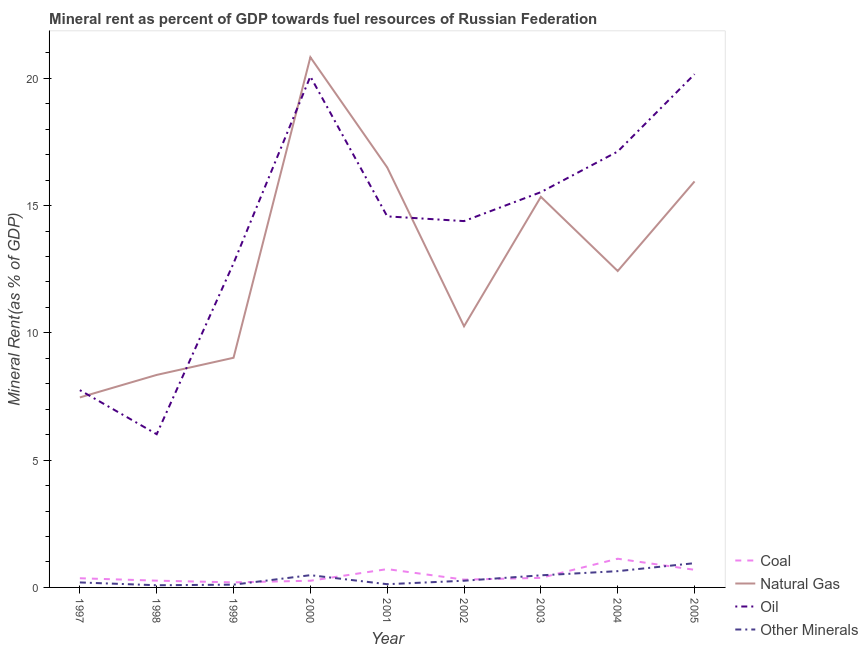How many different coloured lines are there?
Offer a terse response. 4. Does the line corresponding to coal rent intersect with the line corresponding to  rent of other minerals?
Give a very brief answer. Yes. What is the natural gas rent in 2000?
Offer a very short reply. 20.83. Across all years, what is the maximum coal rent?
Keep it short and to the point. 1.13. Across all years, what is the minimum coal rent?
Your answer should be very brief. 0.2. In which year was the natural gas rent maximum?
Your response must be concise. 2000. In which year was the natural gas rent minimum?
Ensure brevity in your answer.  1997. What is the total  rent of other minerals in the graph?
Your answer should be compact. 3.33. What is the difference between the  rent of other minerals in 1999 and that in 2001?
Ensure brevity in your answer.  -0.02. What is the difference between the  rent of other minerals in 2005 and the coal rent in 2003?
Give a very brief answer. 0.58. What is the average  rent of other minerals per year?
Offer a terse response. 0.37. In the year 1997, what is the difference between the  rent of other minerals and coal rent?
Provide a succinct answer. -0.16. In how many years, is the  rent of other minerals greater than 18 %?
Your answer should be very brief. 0. What is the ratio of the  rent of other minerals in 1997 to that in 2004?
Make the answer very short. 0.31. Is the difference between the  rent of other minerals in 2000 and 2003 greater than the difference between the coal rent in 2000 and 2003?
Your response must be concise. Yes. What is the difference between the highest and the second highest oil rent?
Your answer should be compact. 0.09. What is the difference between the highest and the lowest oil rent?
Give a very brief answer. 14.14. In how many years, is the  rent of other minerals greater than the average  rent of other minerals taken over all years?
Provide a succinct answer. 4. Is it the case that in every year, the sum of the coal rent and natural gas rent is greater than the oil rent?
Provide a succinct answer. No. Does the oil rent monotonically increase over the years?
Your response must be concise. No. Is the coal rent strictly less than the  rent of other minerals over the years?
Offer a very short reply. No. How many years are there in the graph?
Offer a terse response. 9. What is the difference between two consecutive major ticks on the Y-axis?
Your answer should be compact. 5. Are the values on the major ticks of Y-axis written in scientific E-notation?
Ensure brevity in your answer.  No. Does the graph contain grids?
Provide a short and direct response. No. Where does the legend appear in the graph?
Your answer should be very brief. Bottom right. How many legend labels are there?
Your answer should be very brief. 4. What is the title of the graph?
Offer a very short reply. Mineral rent as percent of GDP towards fuel resources of Russian Federation. What is the label or title of the Y-axis?
Offer a very short reply. Mineral Rent(as % of GDP). What is the Mineral Rent(as % of GDP) in Coal in 1997?
Offer a terse response. 0.36. What is the Mineral Rent(as % of GDP) in Natural Gas in 1997?
Offer a very short reply. 7.46. What is the Mineral Rent(as % of GDP) of Oil in 1997?
Offer a terse response. 7.75. What is the Mineral Rent(as % of GDP) in Other Minerals in 1997?
Your answer should be very brief. 0.2. What is the Mineral Rent(as % of GDP) in Coal in 1998?
Keep it short and to the point. 0.27. What is the Mineral Rent(as % of GDP) in Natural Gas in 1998?
Keep it short and to the point. 8.35. What is the Mineral Rent(as % of GDP) of Oil in 1998?
Ensure brevity in your answer.  6.02. What is the Mineral Rent(as % of GDP) in Other Minerals in 1998?
Give a very brief answer. 0.09. What is the Mineral Rent(as % of GDP) of Coal in 1999?
Your answer should be very brief. 0.2. What is the Mineral Rent(as % of GDP) in Natural Gas in 1999?
Provide a succinct answer. 9.02. What is the Mineral Rent(as % of GDP) in Oil in 1999?
Your response must be concise. 12.73. What is the Mineral Rent(as % of GDP) of Other Minerals in 1999?
Your response must be concise. 0.11. What is the Mineral Rent(as % of GDP) in Coal in 2000?
Offer a terse response. 0.26. What is the Mineral Rent(as % of GDP) of Natural Gas in 2000?
Provide a succinct answer. 20.83. What is the Mineral Rent(as % of GDP) in Oil in 2000?
Offer a very short reply. 20.07. What is the Mineral Rent(as % of GDP) of Other Minerals in 2000?
Keep it short and to the point. 0.48. What is the Mineral Rent(as % of GDP) of Coal in 2001?
Your answer should be very brief. 0.72. What is the Mineral Rent(as % of GDP) in Natural Gas in 2001?
Your answer should be compact. 16.5. What is the Mineral Rent(as % of GDP) in Oil in 2001?
Offer a terse response. 14.57. What is the Mineral Rent(as % of GDP) in Other Minerals in 2001?
Give a very brief answer. 0.13. What is the Mineral Rent(as % of GDP) of Coal in 2002?
Provide a succinct answer. 0.31. What is the Mineral Rent(as % of GDP) of Natural Gas in 2002?
Offer a terse response. 10.26. What is the Mineral Rent(as % of GDP) in Oil in 2002?
Your answer should be very brief. 14.39. What is the Mineral Rent(as % of GDP) of Other Minerals in 2002?
Give a very brief answer. 0.26. What is the Mineral Rent(as % of GDP) in Coal in 2003?
Make the answer very short. 0.38. What is the Mineral Rent(as % of GDP) in Natural Gas in 2003?
Provide a short and direct response. 15.34. What is the Mineral Rent(as % of GDP) of Oil in 2003?
Offer a terse response. 15.53. What is the Mineral Rent(as % of GDP) of Other Minerals in 2003?
Provide a succinct answer. 0.48. What is the Mineral Rent(as % of GDP) in Coal in 2004?
Ensure brevity in your answer.  1.13. What is the Mineral Rent(as % of GDP) of Natural Gas in 2004?
Your answer should be compact. 12.43. What is the Mineral Rent(as % of GDP) in Oil in 2004?
Provide a succinct answer. 17.12. What is the Mineral Rent(as % of GDP) in Other Minerals in 2004?
Your response must be concise. 0.64. What is the Mineral Rent(as % of GDP) of Coal in 2005?
Keep it short and to the point. 0.69. What is the Mineral Rent(as % of GDP) in Natural Gas in 2005?
Keep it short and to the point. 15.95. What is the Mineral Rent(as % of GDP) of Oil in 2005?
Give a very brief answer. 20.16. What is the Mineral Rent(as % of GDP) of Other Minerals in 2005?
Ensure brevity in your answer.  0.95. Across all years, what is the maximum Mineral Rent(as % of GDP) in Coal?
Make the answer very short. 1.13. Across all years, what is the maximum Mineral Rent(as % of GDP) in Natural Gas?
Give a very brief answer. 20.83. Across all years, what is the maximum Mineral Rent(as % of GDP) of Oil?
Your answer should be compact. 20.16. Across all years, what is the maximum Mineral Rent(as % of GDP) in Other Minerals?
Your answer should be very brief. 0.95. Across all years, what is the minimum Mineral Rent(as % of GDP) of Coal?
Give a very brief answer. 0.2. Across all years, what is the minimum Mineral Rent(as % of GDP) of Natural Gas?
Make the answer very short. 7.46. Across all years, what is the minimum Mineral Rent(as % of GDP) in Oil?
Your answer should be compact. 6.02. Across all years, what is the minimum Mineral Rent(as % of GDP) of Other Minerals?
Offer a very short reply. 0.09. What is the total Mineral Rent(as % of GDP) of Coal in the graph?
Make the answer very short. 4.31. What is the total Mineral Rent(as % of GDP) in Natural Gas in the graph?
Keep it short and to the point. 116.13. What is the total Mineral Rent(as % of GDP) in Oil in the graph?
Keep it short and to the point. 128.34. What is the total Mineral Rent(as % of GDP) in Other Minerals in the graph?
Give a very brief answer. 3.33. What is the difference between the Mineral Rent(as % of GDP) in Coal in 1997 and that in 1998?
Offer a terse response. 0.09. What is the difference between the Mineral Rent(as % of GDP) in Natural Gas in 1997 and that in 1998?
Ensure brevity in your answer.  -0.88. What is the difference between the Mineral Rent(as % of GDP) in Oil in 1997 and that in 1998?
Your response must be concise. 1.73. What is the difference between the Mineral Rent(as % of GDP) in Other Minerals in 1997 and that in 1998?
Ensure brevity in your answer.  0.11. What is the difference between the Mineral Rent(as % of GDP) of Coal in 1997 and that in 1999?
Offer a very short reply. 0.16. What is the difference between the Mineral Rent(as % of GDP) in Natural Gas in 1997 and that in 1999?
Give a very brief answer. -1.56. What is the difference between the Mineral Rent(as % of GDP) in Oil in 1997 and that in 1999?
Ensure brevity in your answer.  -4.98. What is the difference between the Mineral Rent(as % of GDP) of Other Minerals in 1997 and that in 1999?
Keep it short and to the point. 0.09. What is the difference between the Mineral Rent(as % of GDP) in Coal in 1997 and that in 2000?
Your response must be concise. 0.1. What is the difference between the Mineral Rent(as % of GDP) of Natural Gas in 1997 and that in 2000?
Make the answer very short. -13.36. What is the difference between the Mineral Rent(as % of GDP) of Oil in 1997 and that in 2000?
Offer a very short reply. -12.32. What is the difference between the Mineral Rent(as % of GDP) of Other Minerals in 1997 and that in 2000?
Your answer should be very brief. -0.29. What is the difference between the Mineral Rent(as % of GDP) in Coal in 1997 and that in 2001?
Ensure brevity in your answer.  -0.36. What is the difference between the Mineral Rent(as % of GDP) in Natural Gas in 1997 and that in 2001?
Your answer should be compact. -9.03. What is the difference between the Mineral Rent(as % of GDP) of Oil in 1997 and that in 2001?
Your answer should be compact. -6.83. What is the difference between the Mineral Rent(as % of GDP) of Other Minerals in 1997 and that in 2001?
Provide a short and direct response. 0.07. What is the difference between the Mineral Rent(as % of GDP) in Coal in 1997 and that in 2002?
Your response must be concise. 0.05. What is the difference between the Mineral Rent(as % of GDP) of Natural Gas in 1997 and that in 2002?
Provide a short and direct response. -2.8. What is the difference between the Mineral Rent(as % of GDP) of Oil in 1997 and that in 2002?
Offer a very short reply. -6.64. What is the difference between the Mineral Rent(as % of GDP) of Other Minerals in 1997 and that in 2002?
Ensure brevity in your answer.  -0.07. What is the difference between the Mineral Rent(as % of GDP) in Coal in 1997 and that in 2003?
Your answer should be very brief. -0.02. What is the difference between the Mineral Rent(as % of GDP) in Natural Gas in 1997 and that in 2003?
Your answer should be very brief. -7.88. What is the difference between the Mineral Rent(as % of GDP) in Oil in 1997 and that in 2003?
Offer a terse response. -7.78. What is the difference between the Mineral Rent(as % of GDP) of Other Minerals in 1997 and that in 2003?
Provide a succinct answer. -0.28. What is the difference between the Mineral Rent(as % of GDP) of Coal in 1997 and that in 2004?
Your response must be concise. -0.77. What is the difference between the Mineral Rent(as % of GDP) of Natural Gas in 1997 and that in 2004?
Your answer should be compact. -4.97. What is the difference between the Mineral Rent(as % of GDP) in Oil in 1997 and that in 2004?
Provide a succinct answer. -9.37. What is the difference between the Mineral Rent(as % of GDP) in Other Minerals in 1997 and that in 2004?
Your answer should be compact. -0.44. What is the difference between the Mineral Rent(as % of GDP) in Coal in 1997 and that in 2005?
Provide a short and direct response. -0.33. What is the difference between the Mineral Rent(as % of GDP) in Natural Gas in 1997 and that in 2005?
Give a very brief answer. -8.48. What is the difference between the Mineral Rent(as % of GDP) of Oil in 1997 and that in 2005?
Offer a terse response. -12.41. What is the difference between the Mineral Rent(as % of GDP) of Other Minerals in 1997 and that in 2005?
Your answer should be very brief. -0.76. What is the difference between the Mineral Rent(as % of GDP) of Coal in 1998 and that in 1999?
Offer a very short reply. 0.07. What is the difference between the Mineral Rent(as % of GDP) in Natural Gas in 1998 and that in 1999?
Provide a succinct answer. -0.67. What is the difference between the Mineral Rent(as % of GDP) in Oil in 1998 and that in 1999?
Your response must be concise. -6.71. What is the difference between the Mineral Rent(as % of GDP) of Other Minerals in 1998 and that in 1999?
Provide a succinct answer. -0.02. What is the difference between the Mineral Rent(as % of GDP) in Coal in 1998 and that in 2000?
Your answer should be compact. 0. What is the difference between the Mineral Rent(as % of GDP) of Natural Gas in 1998 and that in 2000?
Your answer should be very brief. -12.48. What is the difference between the Mineral Rent(as % of GDP) in Oil in 1998 and that in 2000?
Give a very brief answer. -14.05. What is the difference between the Mineral Rent(as % of GDP) of Other Minerals in 1998 and that in 2000?
Your answer should be very brief. -0.4. What is the difference between the Mineral Rent(as % of GDP) in Coal in 1998 and that in 2001?
Provide a succinct answer. -0.45. What is the difference between the Mineral Rent(as % of GDP) in Natural Gas in 1998 and that in 2001?
Your response must be concise. -8.15. What is the difference between the Mineral Rent(as % of GDP) of Oil in 1998 and that in 2001?
Provide a short and direct response. -8.56. What is the difference between the Mineral Rent(as % of GDP) in Other Minerals in 1998 and that in 2001?
Provide a succinct answer. -0.04. What is the difference between the Mineral Rent(as % of GDP) of Coal in 1998 and that in 2002?
Give a very brief answer. -0.04. What is the difference between the Mineral Rent(as % of GDP) of Natural Gas in 1998 and that in 2002?
Provide a short and direct response. -1.91. What is the difference between the Mineral Rent(as % of GDP) in Oil in 1998 and that in 2002?
Your response must be concise. -8.37. What is the difference between the Mineral Rent(as % of GDP) in Other Minerals in 1998 and that in 2002?
Offer a very short reply. -0.18. What is the difference between the Mineral Rent(as % of GDP) of Coal in 1998 and that in 2003?
Provide a short and direct response. -0.11. What is the difference between the Mineral Rent(as % of GDP) in Natural Gas in 1998 and that in 2003?
Provide a short and direct response. -7. What is the difference between the Mineral Rent(as % of GDP) in Oil in 1998 and that in 2003?
Keep it short and to the point. -9.51. What is the difference between the Mineral Rent(as % of GDP) of Other Minerals in 1998 and that in 2003?
Your answer should be very brief. -0.39. What is the difference between the Mineral Rent(as % of GDP) in Coal in 1998 and that in 2004?
Give a very brief answer. -0.86. What is the difference between the Mineral Rent(as % of GDP) in Natural Gas in 1998 and that in 2004?
Make the answer very short. -4.08. What is the difference between the Mineral Rent(as % of GDP) of Oil in 1998 and that in 2004?
Your response must be concise. -11.1. What is the difference between the Mineral Rent(as % of GDP) of Other Minerals in 1998 and that in 2004?
Ensure brevity in your answer.  -0.55. What is the difference between the Mineral Rent(as % of GDP) of Coal in 1998 and that in 2005?
Ensure brevity in your answer.  -0.43. What is the difference between the Mineral Rent(as % of GDP) in Natural Gas in 1998 and that in 2005?
Your answer should be compact. -7.6. What is the difference between the Mineral Rent(as % of GDP) of Oil in 1998 and that in 2005?
Your answer should be compact. -14.14. What is the difference between the Mineral Rent(as % of GDP) of Other Minerals in 1998 and that in 2005?
Your answer should be very brief. -0.87. What is the difference between the Mineral Rent(as % of GDP) in Coal in 1999 and that in 2000?
Keep it short and to the point. -0.06. What is the difference between the Mineral Rent(as % of GDP) of Natural Gas in 1999 and that in 2000?
Offer a very short reply. -11.81. What is the difference between the Mineral Rent(as % of GDP) in Oil in 1999 and that in 2000?
Your response must be concise. -7.34. What is the difference between the Mineral Rent(as % of GDP) of Other Minerals in 1999 and that in 2000?
Provide a succinct answer. -0.37. What is the difference between the Mineral Rent(as % of GDP) of Coal in 1999 and that in 2001?
Your answer should be very brief. -0.52. What is the difference between the Mineral Rent(as % of GDP) in Natural Gas in 1999 and that in 2001?
Offer a terse response. -7.48. What is the difference between the Mineral Rent(as % of GDP) of Oil in 1999 and that in 2001?
Give a very brief answer. -1.84. What is the difference between the Mineral Rent(as % of GDP) of Other Minerals in 1999 and that in 2001?
Offer a very short reply. -0.02. What is the difference between the Mineral Rent(as % of GDP) in Coal in 1999 and that in 2002?
Make the answer very short. -0.11. What is the difference between the Mineral Rent(as % of GDP) of Natural Gas in 1999 and that in 2002?
Offer a very short reply. -1.24. What is the difference between the Mineral Rent(as % of GDP) of Oil in 1999 and that in 2002?
Offer a very short reply. -1.66. What is the difference between the Mineral Rent(as % of GDP) of Other Minerals in 1999 and that in 2002?
Provide a succinct answer. -0.15. What is the difference between the Mineral Rent(as % of GDP) in Coal in 1999 and that in 2003?
Your answer should be compact. -0.18. What is the difference between the Mineral Rent(as % of GDP) in Natural Gas in 1999 and that in 2003?
Ensure brevity in your answer.  -6.32. What is the difference between the Mineral Rent(as % of GDP) of Oil in 1999 and that in 2003?
Give a very brief answer. -2.79. What is the difference between the Mineral Rent(as % of GDP) of Other Minerals in 1999 and that in 2003?
Keep it short and to the point. -0.37. What is the difference between the Mineral Rent(as % of GDP) of Coal in 1999 and that in 2004?
Make the answer very short. -0.93. What is the difference between the Mineral Rent(as % of GDP) of Natural Gas in 1999 and that in 2004?
Keep it short and to the point. -3.41. What is the difference between the Mineral Rent(as % of GDP) in Oil in 1999 and that in 2004?
Provide a succinct answer. -4.39. What is the difference between the Mineral Rent(as % of GDP) of Other Minerals in 1999 and that in 2004?
Offer a terse response. -0.53. What is the difference between the Mineral Rent(as % of GDP) of Coal in 1999 and that in 2005?
Ensure brevity in your answer.  -0.49. What is the difference between the Mineral Rent(as % of GDP) in Natural Gas in 1999 and that in 2005?
Your answer should be very brief. -6.93. What is the difference between the Mineral Rent(as % of GDP) in Oil in 1999 and that in 2005?
Your answer should be very brief. -7.43. What is the difference between the Mineral Rent(as % of GDP) of Other Minerals in 1999 and that in 2005?
Your answer should be very brief. -0.84. What is the difference between the Mineral Rent(as % of GDP) in Coal in 2000 and that in 2001?
Keep it short and to the point. -0.46. What is the difference between the Mineral Rent(as % of GDP) in Natural Gas in 2000 and that in 2001?
Offer a terse response. 4.33. What is the difference between the Mineral Rent(as % of GDP) of Oil in 2000 and that in 2001?
Ensure brevity in your answer.  5.5. What is the difference between the Mineral Rent(as % of GDP) of Other Minerals in 2000 and that in 2001?
Make the answer very short. 0.35. What is the difference between the Mineral Rent(as % of GDP) of Coal in 2000 and that in 2002?
Give a very brief answer. -0.04. What is the difference between the Mineral Rent(as % of GDP) of Natural Gas in 2000 and that in 2002?
Offer a very short reply. 10.57. What is the difference between the Mineral Rent(as % of GDP) of Oil in 2000 and that in 2002?
Offer a terse response. 5.68. What is the difference between the Mineral Rent(as % of GDP) in Other Minerals in 2000 and that in 2002?
Provide a succinct answer. 0.22. What is the difference between the Mineral Rent(as % of GDP) in Coal in 2000 and that in 2003?
Your response must be concise. -0.11. What is the difference between the Mineral Rent(as % of GDP) in Natural Gas in 2000 and that in 2003?
Your answer should be very brief. 5.48. What is the difference between the Mineral Rent(as % of GDP) of Oil in 2000 and that in 2003?
Make the answer very short. 4.54. What is the difference between the Mineral Rent(as % of GDP) of Other Minerals in 2000 and that in 2003?
Ensure brevity in your answer.  0.01. What is the difference between the Mineral Rent(as % of GDP) of Coal in 2000 and that in 2004?
Your answer should be compact. -0.86. What is the difference between the Mineral Rent(as % of GDP) of Natural Gas in 2000 and that in 2004?
Offer a terse response. 8.4. What is the difference between the Mineral Rent(as % of GDP) in Oil in 2000 and that in 2004?
Keep it short and to the point. 2.95. What is the difference between the Mineral Rent(as % of GDP) in Other Minerals in 2000 and that in 2004?
Offer a very short reply. -0.16. What is the difference between the Mineral Rent(as % of GDP) of Coal in 2000 and that in 2005?
Make the answer very short. -0.43. What is the difference between the Mineral Rent(as % of GDP) of Natural Gas in 2000 and that in 2005?
Offer a very short reply. 4.88. What is the difference between the Mineral Rent(as % of GDP) of Oil in 2000 and that in 2005?
Offer a terse response. -0.09. What is the difference between the Mineral Rent(as % of GDP) of Other Minerals in 2000 and that in 2005?
Give a very brief answer. -0.47. What is the difference between the Mineral Rent(as % of GDP) of Coal in 2001 and that in 2002?
Your response must be concise. 0.41. What is the difference between the Mineral Rent(as % of GDP) in Natural Gas in 2001 and that in 2002?
Your response must be concise. 6.24. What is the difference between the Mineral Rent(as % of GDP) in Oil in 2001 and that in 2002?
Ensure brevity in your answer.  0.19. What is the difference between the Mineral Rent(as % of GDP) in Other Minerals in 2001 and that in 2002?
Your response must be concise. -0.14. What is the difference between the Mineral Rent(as % of GDP) of Coal in 2001 and that in 2003?
Ensure brevity in your answer.  0.34. What is the difference between the Mineral Rent(as % of GDP) in Natural Gas in 2001 and that in 2003?
Your answer should be compact. 1.15. What is the difference between the Mineral Rent(as % of GDP) of Oil in 2001 and that in 2003?
Offer a very short reply. -0.95. What is the difference between the Mineral Rent(as % of GDP) of Other Minerals in 2001 and that in 2003?
Keep it short and to the point. -0.35. What is the difference between the Mineral Rent(as % of GDP) in Coal in 2001 and that in 2004?
Offer a very short reply. -0.41. What is the difference between the Mineral Rent(as % of GDP) in Natural Gas in 2001 and that in 2004?
Make the answer very short. 4.07. What is the difference between the Mineral Rent(as % of GDP) of Oil in 2001 and that in 2004?
Your answer should be compact. -2.55. What is the difference between the Mineral Rent(as % of GDP) in Other Minerals in 2001 and that in 2004?
Your answer should be compact. -0.51. What is the difference between the Mineral Rent(as % of GDP) of Coal in 2001 and that in 2005?
Keep it short and to the point. 0.03. What is the difference between the Mineral Rent(as % of GDP) of Natural Gas in 2001 and that in 2005?
Make the answer very short. 0.55. What is the difference between the Mineral Rent(as % of GDP) in Oil in 2001 and that in 2005?
Your answer should be compact. -5.58. What is the difference between the Mineral Rent(as % of GDP) of Other Minerals in 2001 and that in 2005?
Offer a terse response. -0.83. What is the difference between the Mineral Rent(as % of GDP) of Coal in 2002 and that in 2003?
Give a very brief answer. -0.07. What is the difference between the Mineral Rent(as % of GDP) of Natural Gas in 2002 and that in 2003?
Offer a terse response. -5.08. What is the difference between the Mineral Rent(as % of GDP) in Oil in 2002 and that in 2003?
Keep it short and to the point. -1.14. What is the difference between the Mineral Rent(as % of GDP) in Other Minerals in 2002 and that in 2003?
Your answer should be compact. -0.21. What is the difference between the Mineral Rent(as % of GDP) in Coal in 2002 and that in 2004?
Offer a terse response. -0.82. What is the difference between the Mineral Rent(as % of GDP) in Natural Gas in 2002 and that in 2004?
Offer a very short reply. -2.17. What is the difference between the Mineral Rent(as % of GDP) in Oil in 2002 and that in 2004?
Offer a terse response. -2.73. What is the difference between the Mineral Rent(as % of GDP) of Other Minerals in 2002 and that in 2004?
Ensure brevity in your answer.  -0.38. What is the difference between the Mineral Rent(as % of GDP) in Coal in 2002 and that in 2005?
Your answer should be compact. -0.39. What is the difference between the Mineral Rent(as % of GDP) of Natural Gas in 2002 and that in 2005?
Give a very brief answer. -5.69. What is the difference between the Mineral Rent(as % of GDP) in Oil in 2002 and that in 2005?
Provide a succinct answer. -5.77. What is the difference between the Mineral Rent(as % of GDP) in Other Minerals in 2002 and that in 2005?
Your answer should be compact. -0.69. What is the difference between the Mineral Rent(as % of GDP) of Coal in 2003 and that in 2004?
Provide a short and direct response. -0.75. What is the difference between the Mineral Rent(as % of GDP) in Natural Gas in 2003 and that in 2004?
Your answer should be compact. 2.91. What is the difference between the Mineral Rent(as % of GDP) of Oil in 2003 and that in 2004?
Provide a succinct answer. -1.6. What is the difference between the Mineral Rent(as % of GDP) in Other Minerals in 2003 and that in 2004?
Offer a very short reply. -0.16. What is the difference between the Mineral Rent(as % of GDP) in Coal in 2003 and that in 2005?
Provide a short and direct response. -0.32. What is the difference between the Mineral Rent(as % of GDP) of Natural Gas in 2003 and that in 2005?
Provide a short and direct response. -0.6. What is the difference between the Mineral Rent(as % of GDP) of Oil in 2003 and that in 2005?
Ensure brevity in your answer.  -4.63. What is the difference between the Mineral Rent(as % of GDP) of Other Minerals in 2003 and that in 2005?
Your response must be concise. -0.48. What is the difference between the Mineral Rent(as % of GDP) of Coal in 2004 and that in 2005?
Provide a short and direct response. 0.44. What is the difference between the Mineral Rent(as % of GDP) in Natural Gas in 2004 and that in 2005?
Keep it short and to the point. -3.52. What is the difference between the Mineral Rent(as % of GDP) in Oil in 2004 and that in 2005?
Provide a short and direct response. -3.04. What is the difference between the Mineral Rent(as % of GDP) of Other Minerals in 2004 and that in 2005?
Provide a succinct answer. -0.31. What is the difference between the Mineral Rent(as % of GDP) in Coal in 1997 and the Mineral Rent(as % of GDP) in Natural Gas in 1998?
Ensure brevity in your answer.  -7.99. What is the difference between the Mineral Rent(as % of GDP) in Coal in 1997 and the Mineral Rent(as % of GDP) in Oil in 1998?
Make the answer very short. -5.66. What is the difference between the Mineral Rent(as % of GDP) in Coal in 1997 and the Mineral Rent(as % of GDP) in Other Minerals in 1998?
Keep it short and to the point. 0.27. What is the difference between the Mineral Rent(as % of GDP) of Natural Gas in 1997 and the Mineral Rent(as % of GDP) of Oil in 1998?
Give a very brief answer. 1.44. What is the difference between the Mineral Rent(as % of GDP) of Natural Gas in 1997 and the Mineral Rent(as % of GDP) of Other Minerals in 1998?
Your answer should be compact. 7.38. What is the difference between the Mineral Rent(as % of GDP) of Oil in 1997 and the Mineral Rent(as % of GDP) of Other Minerals in 1998?
Your answer should be very brief. 7.66. What is the difference between the Mineral Rent(as % of GDP) in Coal in 1997 and the Mineral Rent(as % of GDP) in Natural Gas in 1999?
Offer a very short reply. -8.66. What is the difference between the Mineral Rent(as % of GDP) of Coal in 1997 and the Mineral Rent(as % of GDP) of Oil in 1999?
Ensure brevity in your answer.  -12.37. What is the difference between the Mineral Rent(as % of GDP) in Coal in 1997 and the Mineral Rent(as % of GDP) in Other Minerals in 1999?
Offer a very short reply. 0.25. What is the difference between the Mineral Rent(as % of GDP) in Natural Gas in 1997 and the Mineral Rent(as % of GDP) in Oil in 1999?
Ensure brevity in your answer.  -5.27. What is the difference between the Mineral Rent(as % of GDP) of Natural Gas in 1997 and the Mineral Rent(as % of GDP) of Other Minerals in 1999?
Offer a very short reply. 7.35. What is the difference between the Mineral Rent(as % of GDP) in Oil in 1997 and the Mineral Rent(as % of GDP) in Other Minerals in 1999?
Ensure brevity in your answer.  7.64. What is the difference between the Mineral Rent(as % of GDP) of Coal in 1997 and the Mineral Rent(as % of GDP) of Natural Gas in 2000?
Your answer should be very brief. -20.47. What is the difference between the Mineral Rent(as % of GDP) of Coal in 1997 and the Mineral Rent(as % of GDP) of Oil in 2000?
Your answer should be very brief. -19.71. What is the difference between the Mineral Rent(as % of GDP) of Coal in 1997 and the Mineral Rent(as % of GDP) of Other Minerals in 2000?
Provide a short and direct response. -0.12. What is the difference between the Mineral Rent(as % of GDP) of Natural Gas in 1997 and the Mineral Rent(as % of GDP) of Oil in 2000?
Your response must be concise. -12.61. What is the difference between the Mineral Rent(as % of GDP) of Natural Gas in 1997 and the Mineral Rent(as % of GDP) of Other Minerals in 2000?
Your response must be concise. 6.98. What is the difference between the Mineral Rent(as % of GDP) in Oil in 1997 and the Mineral Rent(as % of GDP) in Other Minerals in 2000?
Provide a short and direct response. 7.27. What is the difference between the Mineral Rent(as % of GDP) of Coal in 1997 and the Mineral Rent(as % of GDP) of Natural Gas in 2001?
Your answer should be very brief. -16.14. What is the difference between the Mineral Rent(as % of GDP) of Coal in 1997 and the Mineral Rent(as % of GDP) of Oil in 2001?
Provide a succinct answer. -14.21. What is the difference between the Mineral Rent(as % of GDP) of Coal in 1997 and the Mineral Rent(as % of GDP) of Other Minerals in 2001?
Keep it short and to the point. 0.23. What is the difference between the Mineral Rent(as % of GDP) in Natural Gas in 1997 and the Mineral Rent(as % of GDP) in Oil in 2001?
Offer a terse response. -7.11. What is the difference between the Mineral Rent(as % of GDP) in Natural Gas in 1997 and the Mineral Rent(as % of GDP) in Other Minerals in 2001?
Give a very brief answer. 7.34. What is the difference between the Mineral Rent(as % of GDP) in Oil in 1997 and the Mineral Rent(as % of GDP) in Other Minerals in 2001?
Ensure brevity in your answer.  7.62. What is the difference between the Mineral Rent(as % of GDP) of Coal in 1997 and the Mineral Rent(as % of GDP) of Natural Gas in 2002?
Your response must be concise. -9.9. What is the difference between the Mineral Rent(as % of GDP) in Coal in 1997 and the Mineral Rent(as % of GDP) in Oil in 2002?
Provide a succinct answer. -14.03. What is the difference between the Mineral Rent(as % of GDP) of Coal in 1997 and the Mineral Rent(as % of GDP) of Other Minerals in 2002?
Offer a terse response. 0.1. What is the difference between the Mineral Rent(as % of GDP) in Natural Gas in 1997 and the Mineral Rent(as % of GDP) in Oil in 2002?
Your answer should be very brief. -6.93. What is the difference between the Mineral Rent(as % of GDP) in Natural Gas in 1997 and the Mineral Rent(as % of GDP) in Other Minerals in 2002?
Your answer should be compact. 7.2. What is the difference between the Mineral Rent(as % of GDP) of Oil in 1997 and the Mineral Rent(as % of GDP) of Other Minerals in 2002?
Offer a terse response. 7.49. What is the difference between the Mineral Rent(as % of GDP) in Coal in 1997 and the Mineral Rent(as % of GDP) in Natural Gas in 2003?
Ensure brevity in your answer.  -14.98. What is the difference between the Mineral Rent(as % of GDP) of Coal in 1997 and the Mineral Rent(as % of GDP) of Oil in 2003?
Give a very brief answer. -15.17. What is the difference between the Mineral Rent(as % of GDP) in Coal in 1997 and the Mineral Rent(as % of GDP) in Other Minerals in 2003?
Ensure brevity in your answer.  -0.12. What is the difference between the Mineral Rent(as % of GDP) of Natural Gas in 1997 and the Mineral Rent(as % of GDP) of Oil in 2003?
Provide a short and direct response. -8.06. What is the difference between the Mineral Rent(as % of GDP) of Natural Gas in 1997 and the Mineral Rent(as % of GDP) of Other Minerals in 2003?
Your answer should be very brief. 6.99. What is the difference between the Mineral Rent(as % of GDP) in Oil in 1997 and the Mineral Rent(as % of GDP) in Other Minerals in 2003?
Offer a terse response. 7.27. What is the difference between the Mineral Rent(as % of GDP) in Coal in 1997 and the Mineral Rent(as % of GDP) in Natural Gas in 2004?
Provide a succinct answer. -12.07. What is the difference between the Mineral Rent(as % of GDP) in Coal in 1997 and the Mineral Rent(as % of GDP) in Oil in 2004?
Your answer should be very brief. -16.76. What is the difference between the Mineral Rent(as % of GDP) in Coal in 1997 and the Mineral Rent(as % of GDP) in Other Minerals in 2004?
Make the answer very short. -0.28. What is the difference between the Mineral Rent(as % of GDP) in Natural Gas in 1997 and the Mineral Rent(as % of GDP) in Oil in 2004?
Keep it short and to the point. -9.66. What is the difference between the Mineral Rent(as % of GDP) of Natural Gas in 1997 and the Mineral Rent(as % of GDP) of Other Minerals in 2004?
Your answer should be very brief. 6.82. What is the difference between the Mineral Rent(as % of GDP) of Oil in 1997 and the Mineral Rent(as % of GDP) of Other Minerals in 2004?
Ensure brevity in your answer.  7.11. What is the difference between the Mineral Rent(as % of GDP) of Coal in 1997 and the Mineral Rent(as % of GDP) of Natural Gas in 2005?
Ensure brevity in your answer.  -15.59. What is the difference between the Mineral Rent(as % of GDP) of Coal in 1997 and the Mineral Rent(as % of GDP) of Oil in 2005?
Offer a terse response. -19.8. What is the difference between the Mineral Rent(as % of GDP) in Coal in 1997 and the Mineral Rent(as % of GDP) in Other Minerals in 2005?
Make the answer very short. -0.59. What is the difference between the Mineral Rent(as % of GDP) of Natural Gas in 1997 and the Mineral Rent(as % of GDP) of Oil in 2005?
Give a very brief answer. -12.7. What is the difference between the Mineral Rent(as % of GDP) of Natural Gas in 1997 and the Mineral Rent(as % of GDP) of Other Minerals in 2005?
Provide a short and direct response. 6.51. What is the difference between the Mineral Rent(as % of GDP) in Oil in 1997 and the Mineral Rent(as % of GDP) in Other Minerals in 2005?
Ensure brevity in your answer.  6.8. What is the difference between the Mineral Rent(as % of GDP) in Coal in 1998 and the Mineral Rent(as % of GDP) in Natural Gas in 1999?
Keep it short and to the point. -8.75. What is the difference between the Mineral Rent(as % of GDP) of Coal in 1998 and the Mineral Rent(as % of GDP) of Oil in 1999?
Provide a short and direct response. -12.46. What is the difference between the Mineral Rent(as % of GDP) of Coal in 1998 and the Mineral Rent(as % of GDP) of Other Minerals in 1999?
Provide a succinct answer. 0.16. What is the difference between the Mineral Rent(as % of GDP) of Natural Gas in 1998 and the Mineral Rent(as % of GDP) of Oil in 1999?
Make the answer very short. -4.38. What is the difference between the Mineral Rent(as % of GDP) of Natural Gas in 1998 and the Mineral Rent(as % of GDP) of Other Minerals in 1999?
Keep it short and to the point. 8.24. What is the difference between the Mineral Rent(as % of GDP) in Oil in 1998 and the Mineral Rent(as % of GDP) in Other Minerals in 1999?
Keep it short and to the point. 5.91. What is the difference between the Mineral Rent(as % of GDP) of Coal in 1998 and the Mineral Rent(as % of GDP) of Natural Gas in 2000?
Ensure brevity in your answer.  -20.56. What is the difference between the Mineral Rent(as % of GDP) of Coal in 1998 and the Mineral Rent(as % of GDP) of Oil in 2000?
Make the answer very short. -19.8. What is the difference between the Mineral Rent(as % of GDP) in Coal in 1998 and the Mineral Rent(as % of GDP) in Other Minerals in 2000?
Your answer should be very brief. -0.21. What is the difference between the Mineral Rent(as % of GDP) of Natural Gas in 1998 and the Mineral Rent(as % of GDP) of Oil in 2000?
Your answer should be very brief. -11.72. What is the difference between the Mineral Rent(as % of GDP) in Natural Gas in 1998 and the Mineral Rent(as % of GDP) in Other Minerals in 2000?
Your response must be concise. 7.87. What is the difference between the Mineral Rent(as % of GDP) of Oil in 1998 and the Mineral Rent(as % of GDP) of Other Minerals in 2000?
Give a very brief answer. 5.54. What is the difference between the Mineral Rent(as % of GDP) in Coal in 1998 and the Mineral Rent(as % of GDP) in Natural Gas in 2001?
Your answer should be compact. -16.23. What is the difference between the Mineral Rent(as % of GDP) of Coal in 1998 and the Mineral Rent(as % of GDP) of Oil in 2001?
Your response must be concise. -14.31. What is the difference between the Mineral Rent(as % of GDP) of Coal in 1998 and the Mineral Rent(as % of GDP) of Other Minerals in 2001?
Offer a very short reply. 0.14. What is the difference between the Mineral Rent(as % of GDP) of Natural Gas in 1998 and the Mineral Rent(as % of GDP) of Oil in 2001?
Make the answer very short. -6.23. What is the difference between the Mineral Rent(as % of GDP) of Natural Gas in 1998 and the Mineral Rent(as % of GDP) of Other Minerals in 2001?
Ensure brevity in your answer.  8.22. What is the difference between the Mineral Rent(as % of GDP) of Oil in 1998 and the Mineral Rent(as % of GDP) of Other Minerals in 2001?
Offer a terse response. 5.89. What is the difference between the Mineral Rent(as % of GDP) in Coal in 1998 and the Mineral Rent(as % of GDP) in Natural Gas in 2002?
Provide a short and direct response. -9.99. What is the difference between the Mineral Rent(as % of GDP) of Coal in 1998 and the Mineral Rent(as % of GDP) of Oil in 2002?
Your answer should be compact. -14.12. What is the difference between the Mineral Rent(as % of GDP) of Coal in 1998 and the Mineral Rent(as % of GDP) of Other Minerals in 2002?
Your answer should be compact. 0. What is the difference between the Mineral Rent(as % of GDP) in Natural Gas in 1998 and the Mineral Rent(as % of GDP) in Oil in 2002?
Make the answer very short. -6.04. What is the difference between the Mineral Rent(as % of GDP) of Natural Gas in 1998 and the Mineral Rent(as % of GDP) of Other Minerals in 2002?
Your answer should be very brief. 8.08. What is the difference between the Mineral Rent(as % of GDP) of Oil in 1998 and the Mineral Rent(as % of GDP) of Other Minerals in 2002?
Your answer should be compact. 5.76. What is the difference between the Mineral Rent(as % of GDP) in Coal in 1998 and the Mineral Rent(as % of GDP) in Natural Gas in 2003?
Ensure brevity in your answer.  -15.08. What is the difference between the Mineral Rent(as % of GDP) in Coal in 1998 and the Mineral Rent(as % of GDP) in Oil in 2003?
Your answer should be compact. -15.26. What is the difference between the Mineral Rent(as % of GDP) in Coal in 1998 and the Mineral Rent(as % of GDP) in Other Minerals in 2003?
Make the answer very short. -0.21. What is the difference between the Mineral Rent(as % of GDP) of Natural Gas in 1998 and the Mineral Rent(as % of GDP) of Oil in 2003?
Offer a terse response. -7.18. What is the difference between the Mineral Rent(as % of GDP) of Natural Gas in 1998 and the Mineral Rent(as % of GDP) of Other Minerals in 2003?
Give a very brief answer. 7.87. What is the difference between the Mineral Rent(as % of GDP) in Oil in 1998 and the Mineral Rent(as % of GDP) in Other Minerals in 2003?
Your answer should be very brief. 5.54. What is the difference between the Mineral Rent(as % of GDP) of Coal in 1998 and the Mineral Rent(as % of GDP) of Natural Gas in 2004?
Your response must be concise. -12.16. What is the difference between the Mineral Rent(as % of GDP) of Coal in 1998 and the Mineral Rent(as % of GDP) of Oil in 2004?
Ensure brevity in your answer.  -16.86. What is the difference between the Mineral Rent(as % of GDP) of Coal in 1998 and the Mineral Rent(as % of GDP) of Other Minerals in 2004?
Your answer should be compact. -0.37. What is the difference between the Mineral Rent(as % of GDP) in Natural Gas in 1998 and the Mineral Rent(as % of GDP) in Oil in 2004?
Your response must be concise. -8.77. What is the difference between the Mineral Rent(as % of GDP) of Natural Gas in 1998 and the Mineral Rent(as % of GDP) of Other Minerals in 2004?
Offer a very short reply. 7.71. What is the difference between the Mineral Rent(as % of GDP) in Oil in 1998 and the Mineral Rent(as % of GDP) in Other Minerals in 2004?
Keep it short and to the point. 5.38. What is the difference between the Mineral Rent(as % of GDP) of Coal in 1998 and the Mineral Rent(as % of GDP) of Natural Gas in 2005?
Your answer should be very brief. -15.68. What is the difference between the Mineral Rent(as % of GDP) in Coal in 1998 and the Mineral Rent(as % of GDP) in Oil in 2005?
Your answer should be compact. -19.89. What is the difference between the Mineral Rent(as % of GDP) in Coal in 1998 and the Mineral Rent(as % of GDP) in Other Minerals in 2005?
Make the answer very short. -0.69. What is the difference between the Mineral Rent(as % of GDP) of Natural Gas in 1998 and the Mineral Rent(as % of GDP) of Oil in 2005?
Offer a very short reply. -11.81. What is the difference between the Mineral Rent(as % of GDP) in Natural Gas in 1998 and the Mineral Rent(as % of GDP) in Other Minerals in 2005?
Ensure brevity in your answer.  7.39. What is the difference between the Mineral Rent(as % of GDP) in Oil in 1998 and the Mineral Rent(as % of GDP) in Other Minerals in 2005?
Your answer should be compact. 5.07. What is the difference between the Mineral Rent(as % of GDP) of Coal in 1999 and the Mineral Rent(as % of GDP) of Natural Gas in 2000?
Keep it short and to the point. -20.63. What is the difference between the Mineral Rent(as % of GDP) in Coal in 1999 and the Mineral Rent(as % of GDP) in Oil in 2000?
Give a very brief answer. -19.87. What is the difference between the Mineral Rent(as % of GDP) in Coal in 1999 and the Mineral Rent(as % of GDP) in Other Minerals in 2000?
Keep it short and to the point. -0.28. What is the difference between the Mineral Rent(as % of GDP) of Natural Gas in 1999 and the Mineral Rent(as % of GDP) of Oil in 2000?
Keep it short and to the point. -11.05. What is the difference between the Mineral Rent(as % of GDP) in Natural Gas in 1999 and the Mineral Rent(as % of GDP) in Other Minerals in 2000?
Your answer should be very brief. 8.54. What is the difference between the Mineral Rent(as % of GDP) in Oil in 1999 and the Mineral Rent(as % of GDP) in Other Minerals in 2000?
Give a very brief answer. 12.25. What is the difference between the Mineral Rent(as % of GDP) in Coal in 1999 and the Mineral Rent(as % of GDP) in Natural Gas in 2001?
Offer a very short reply. -16.3. What is the difference between the Mineral Rent(as % of GDP) in Coal in 1999 and the Mineral Rent(as % of GDP) in Oil in 2001?
Your answer should be very brief. -14.38. What is the difference between the Mineral Rent(as % of GDP) in Coal in 1999 and the Mineral Rent(as % of GDP) in Other Minerals in 2001?
Your answer should be very brief. 0.07. What is the difference between the Mineral Rent(as % of GDP) in Natural Gas in 1999 and the Mineral Rent(as % of GDP) in Oil in 2001?
Offer a very short reply. -5.55. What is the difference between the Mineral Rent(as % of GDP) of Natural Gas in 1999 and the Mineral Rent(as % of GDP) of Other Minerals in 2001?
Your answer should be compact. 8.89. What is the difference between the Mineral Rent(as % of GDP) in Oil in 1999 and the Mineral Rent(as % of GDP) in Other Minerals in 2001?
Your answer should be very brief. 12.6. What is the difference between the Mineral Rent(as % of GDP) of Coal in 1999 and the Mineral Rent(as % of GDP) of Natural Gas in 2002?
Keep it short and to the point. -10.06. What is the difference between the Mineral Rent(as % of GDP) of Coal in 1999 and the Mineral Rent(as % of GDP) of Oil in 2002?
Offer a terse response. -14.19. What is the difference between the Mineral Rent(as % of GDP) of Coal in 1999 and the Mineral Rent(as % of GDP) of Other Minerals in 2002?
Make the answer very short. -0.06. What is the difference between the Mineral Rent(as % of GDP) in Natural Gas in 1999 and the Mineral Rent(as % of GDP) in Oil in 2002?
Offer a terse response. -5.37. What is the difference between the Mineral Rent(as % of GDP) of Natural Gas in 1999 and the Mineral Rent(as % of GDP) of Other Minerals in 2002?
Your answer should be very brief. 8.76. What is the difference between the Mineral Rent(as % of GDP) of Oil in 1999 and the Mineral Rent(as % of GDP) of Other Minerals in 2002?
Provide a succinct answer. 12.47. What is the difference between the Mineral Rent(as % of GDP) of Coal in 1999 and the Mineral Rent(as % of GDP) of Natural Gas in 2003?
Your response must be concise. -15.14. What is the difference between the Mineral Rent(as % of GDP) of Coal in 1999 and the Mineral Rent(as % of GDP) of Oil in 2003?
Give a very brief answer. -15.33. What is the difference between the Mineral Rent(as % of GDP) of Coal in 1999 and the Mineral Rent(as % of GDP) of Other Minerals in 2003?
Give a very brief answer. -0.28. What is the difference between the Mineral Rent(as % of GDP) of Natural Gas in 1999 and the Mineral Rent(as % of GDP) of Oil in 2003?
Provide a succinct answer. -6.51. What is the difference between the Mineral Rent(as % of GDP) of Natural Gas in 1999 and the Mineral Rent(as % of GDP) of Other Minerals in 2003?
Your answer should be very brief. 8.54. What is the difference between the Mineral Rent(as % of GDP) of Oil in 1999 and the Mineral Rent(as % of GDP) of Other Minerals in 2003?
Make the answer very short. 12.26. What is the difference between the Mineral Rent(as % of GDP) in Coal in 1999 and the Mineral Rent(as % of GDP) in Natural Gas in 2004?
Offer a terse response. -12.23. What is the difference between the Mineral Rent(as % of GDP) of Coal in 1999 and the Mineral Rent(as % of GDP) of Oil in 2004?
Keep it short and to the point. -16.92. What is the difference between the Mineral Rent(as % of GDP) of Coal in 1999 and the Mineral Rent(as % of GDP) of Other Minerals in 2004?
Provide a short and direct response. -0.44. What is the difference between the Mineral Rent(as % of GDP) of Natural Gas in 1999 and the Mineral Rent(as % of GDP) of Oil in 2004?
Offer a very short reply. -8.1. What is the difference between the Mineral Rent(as % of GDP) in Natural Gas in 1999 and the Mineral Rent(as % of GDP) in Other Minerals in 2004?
Provide a succinct answer. 8.38. What is the difference between the Mineral Rent(as % of GDP) in Oil in 1999 and the Mineral Rent(as % of GDP) in Other Minerals in 2004?
Make the answer very short. 12.09. What is the difference between the Mineral Rent(as % of GDP) in Coal in 1999 and the Mineral Rent(as % of GDP) in Natural Gas in 2005?
Ensure brevity in your answer.  -15.75. What is the difference between the Mineral Rent(as % of GDP) in Coal in 1999 and the Mineral Rent(as % of GDP) in Oil in 2005?
Ensure brevity in your answer.  -19.96. What is the difference between the Mineral Rent(as % of GDP) in Coal in 1999 and the Mineral Rent(as % of GDP) in Other Minerals in 2005?
Your answer should be compact. -0.75. What is the difference between the Mineral Rent(as % of GDP) of Natural Gas in 1999 and the Mineral Rent(as % of GDP) of Oil in 2005?
Offer a terse response. -11.14. What is the difference between the Mineral Rent(as % of GDP) in Natural Gas in 1999 and the Mineral Rent(as % of GDP) in Other Minerals in 2005?
Give a very brief answer. 8.07. What is the difference between the Mineral Rent(as % of GDP) of Oil in 1999 and the Mineral Rent(as % of GDP) of Other Minerals in 2005?
Your answer should be very brief. 11.78. What is the difference between the Mineral Rent(as % of GDP) in Coal in 2000 and the Mineral Rent(as % of GDP) in Natural Gas in 2001?
Offer a very short reply. -16.23. What is the difference between the Mineral Rent(as % of GDP) in Coal in 2000 and the Mineral Rent(as % of GDP) in Oil in 2001?
Ensure brevity in your answer.  -14.31. What is the difference between the Mineral Rent(as % of GDP) in Coal in 2000 and the Mineral Rent(as % of GDP) in Other Minerals in 2001?
Keep it short and to the point. 0.14. What is the difference between the Mineral Rent(as % of GDP) in Natural Gas in 2000 and the Mineral Rent(as % of GDP) in Oil in 2001?
Offer a very short reply. 6.25. What is the difference between the Mineral Rent(as % of GDP) of Natural Gas in 2000 and the Mineral Rent(as % of GDP) of Other Minerals in 2001?
Ensure brevity in your answer.  20.7. What is the difference between the Mineral Rent(as % of GDP) in Oil in 2000 and the Mineral Rent(as % of GDP) in Other Minerals in 2001?
Your answer should be compact. 19.94. What is the difference between the Mineral Rent(as % of GDP) in Coal in 2000 and the Mineral Rent(as % of GDP) in Natural Gas in 2002?
Keep it short and to the point. -10. What is the difference between the Mineral Rent(as % of GDP) of Coal in 2000 and the Mineral Rent(as % of GDP) of Oil in 2002?
Offer a very short reply. -14.13. What is the difference between the Mineral Rent(as % of GDP) of Coal in 2000 and the Mineral Rent(as % of GDP) of Other Minerals in 2002?
Make the answer very short. -0. What is the difference between the Mineral Rent(as % of GDP) of Natural Gas in 2000 and the Mineral Rent(as % of GDP) of Oil in 2002?
Offer a very short reply. 6.44. What is the difference between the Mineral Rent(as % of GDP) of Natural Gas in 2000 and the Mineral Rent(as % of GDP) of Other Minerals in 2002?
Ensure brevity in your answer.  20.56. What is the difference between the Mineral Rent(as % of GDP) of Oil in 2000 and the Mineral Rent(as % of GDP) of Other Minerals in 2002?
Keep it short and to the point. 19.81. What is the difference between the Mineral Rent(as % of GDP) in Coal in 2000 and the Mineral Rent(as % of GDP) in Natural Gas in 2003?
Give a very brief answer. -15.08. What is the difference between the Mineral Rent(as % of GDP) of Coal in 2000 and the Mineral Rent(as % of GDP) of Oil in 2003?
Keep it short and to the point. -15.26. What is the difference between the Mineral Rent(as % of GDP) of Coal in 2000 and the Mineral Rent(as % of GDP) of Other Minerals in 2003?
Make the answer very short. -0.21. What is the difference between the Mineral Rent(as % of GDP) of Natural Gas in 2000 and the Mineral Rent(as % of GDP) of Oil in 2003?
Offer a very short reply. 5.3. What is the difference between the Mineral Rent(as % of GDP) of Natural Gas in 2000 and the Mineral Rent(as % of GDP) of Other Minerals in 2003?
Your answer should be compact. 20.35. What is the difference between the Mineral Rent(as % of GDP) in Oil in 2000 and the Mineral Rent(as % of GDP) in Other Minerals in 2003?
Your response must be concise. 19.6. What is the difference between the Mineral Rent(as % of GDP) in Coal in 2000 and the Mineral Rent(as % of GDP) in Natural Gas in 2004?
Your answer should be very brief. -12.17. What is the difference between the Mineral Rent(as % of GDP) of Coal in 2000 and the Mineral Rent(as % of GDP) of Oil in 2004?
Keep it short and to the point. -16.86. What is the difference between the Mineral Rent(as % of GDP) of Coal in 2000 and the Mineral Rent(as % of GDP) of Other Minerals in 2004?
Give a very brief answer. -0.38. What is the difference between the Mineral Rent(as % of GDP) of Natural Gas in 2000 and the Mineral Rent(as % of GDP) of Oil in 2004?
Offer a terse response. 3.7. What is the difference between the Mineral Rent(as % of GDP) in Natural Gas in 2000 and the Mineral Rent(as % of GDP) in Other Minerals in 2004?
Your answer should be compact. 20.19. What is the difference between the Mineral Rent(as % of GDP) of Oil in 2000 and the Mineral Rent(as % of GDP) of Other Minerals in 2004?
Offer a terse response. 19.43. What is the difference between the Mineral Rent(as % of GDP) in Coal in 2000 and the Mineral Rent(as % of GDP) in Natural Gas in 2005?
Offer a terse response. -15.68. What is the difference between the Mineral Rent(as % of GDP) of Coal in 2000 and the Mineral Rent(as % of GDP) of Oil in 2005?
Offer a very short reply. -19.9. What is the difference between the Mineral Rent(as % of GDP) of Coal in 2000 and the Mineral Rent(as % of GDP) of Other Minerals in 2005?
Ensure brevity in your answer.  -0.69. What is the difference between the Mineral Rent(as % of GDP) in Natural Gas in 2000 and the Mineral Rent(as % of GDP) in Oil in 2005?
Offer a terse response. 0.67. What is the difference between the Mineral Rent(as % of GDP) of Natural Gas in 2000 and the Mineral Rent(as % of GDP) of Other Minerals in 2005?
Give a very brief answer. 19.87. What is the difference between the Mineral Rent(as % of GDP) of Oil in 2000 and the Mineral Rent(as % of GDP) of Other Minerals in 2005?
Make the answer very short. 19.12. What is the difference between the Mineral Rent(as % of GDP) of Coal in 2001 and the Mineral Rent(as % of GDP) of Natural Gas in 2002?
Provide a short and direct response. -9.54. What is the difference between the Mineral Rent(as % of GDP) of Coal in 2001 and the Mineral Rent(as % of GDP) of Oil in 2002?
Provide a short and direct response. -13.67. What is the difference between the Mineral Rent(as % of GDP) in Coal in 2001 and the Mineral Rent(as % of GDP) in Other Minerals in 2002?
Your answer should be compact. 0.46. What is the difference between the Mineral Rent(as % of GDP) in Natural Gas in 2001 and the Mineral Rent(as % of GDP) in Oil in 2002?
Provide a short and direct response. 2.11. What is the difference between the Mineral Rent(as % of GDP) in Natural Gas in 2001 and the Mineral Rent(as % of GDP) in Other Minerals in 2002?
Ensure brevity in your answer.  16.23. What is the difference between the Mineral Rent(as % of GDP) of Oil in 2001 and the Mineral Rent(as % of GDP) of Other Minerals in 2002?
Give a very brief answer. 14.31. What is the difference between the Mineral Rent(as % of GDP) of Coal in 2001 and the Mineral Rent(as % of GDP) of Natural Gas in 2003?
Your answer should be compact. -14.62. What is the difference between the Mineral Rent(as % of GDP) of Coal in 2001 and the Mineral Rent(as % of GDP) of Oil in 2003?
Keep it short and to the point. -14.81. What is the difference between the Mineral Rent(as % of GDP) of Coal in 2001 and the Mineral Rent(as % of GDP) of Other Minerals in 2003?
Ensure brevity in your answer.  0.24. What is the difference between the Mineral Rent(as % of GDP) in Natural Gas in 2001 and the Mineral Rent(as % of GDP) in Oil in 2003?
Offer a terse response. 0.97. What is the difference between the Mineral Rent(as % of GDP) in Natural Gas in 2001 and the Mineral Rent(as % of GDP) in Other Minerals in 2003?
Make the answer very short. 16.02. What is the difference between the Mineral Rent(as % of GDP) of Oil in 2001 and the Mineral Rent(as % of GDP) of Other Minerals in 2003?
Your response must be concise. 14.1. What is the difference between the Mineral Rent(as % of GDP) in Coal in 2001 and the Mineral Rent(as % of GDP) in Natural Gas in 2004?
Provide a succinct answer. -11.71. What is the difference between the Mineral Rent(as % of GDP) of Coal in 2001 and the Mineral Rent(as % of GDP) of Oil in 2004?
Your answer should be compact. -16.4. What is the difference between the Mineral Rent(as % of GDP) of Natural Gas in 2001 and the Mineral Rent(as % of GDP) of Oil in 2004?
Offer a terse response. -0.62. What is the difference between the Mineral Rent(as % of GDP) of Natural Gas in 2001 and the Mineral Rent(as % of GDP) of Other Minerals in 2004?
Keep it short and to the point. 15.86. What is the difference between the Mineral Rent(as % of GDP) of Oil in 2001 and the Mineral Rent(as % of GDP) of Other Minerals in 2004?
Give a very brief answer. 13.94. What is the difference between the Mineral Rent(as % of GDP) in Coal in 2001 and the Mineral Rent(as % of GDP) in Natural Gas in 2005?
Provide a succinct answer. -15.23. What is the difference between the Mineral Rent(as % of GDP) of Coal in 2001 and the Mineral Rent(as % of GDP) of Oil in 2005?
Offer a terse response. -19.44. What is the difference between the Mineral Rent(as % of GDP) in Coal in 2001 and the Mineral Rent(as % of GDP) in Other Minerals in 2005?
Keep it short and to the point. -0.23. What is the difference between the Mineral Rent(as % of GDP) in Natural Gas in 2001 and the Mineral Rent(as % of GDP) in Oil in 2005?
Your answer should be compact. -3.66. What is the difference between the Mineral Rent(as % of GDP) in Natural Gas in 2001 and the Mineral Rent(as % of GDP) in Other Minerals in 2005?
Offer a terse response. 15.54. What is the difference between the Mineral Rent(as % of GDP) of Oil in 2001 and the Mineral Rent(as % of GDP) of Other Minerals in 2005?
Make the answer very short. 13.62. What is the difference between the Mineral Rent(as % of GDP) in Coal in 2002 and the Mineral Rent(as % of GDP) in Natural Gas in 2003?
Offer a very short reply. -15.04. What is the difference between the Mineral Rent(as % of GDP) in Coal in 2002 and the Mineral Rent(as % of GDP) in Oil in 2003?
Offer a terse response. -15.22. What is the difference between the Mineral Rent(as % of GDP) of Coal in 2002 and the Mineral Rent(as % of GDP) of Other Minerals in 2003?
Your answer should be compact. -0.17. What is the difference between the Mineral Rent(as % of GDP) in Natural Gas in 2002 and the Mineral Rent(as % of GDP) in Oil in 2003?
Offer a terse response. -5.27. What is the difference between the Mineral Rent(as % of GDP) of Natural Gas in 2002 and the Mineral Rent(as % of GDP) of Other Minerals in 2003?
Provide a short and direct response. 9.78. What is the difference between the Mineral Rent(as % of GDP) of Oil in 2002 and the Mineral Rent(as % of GDP) of Other Minerals in 2003?
Your answer should be very brief. 13.91. What is the difference between the Mineral Rent(as % of GDP) of Coal in 2002 and the Mineral Rent(as % of GDP) of Natural Gas in 2004?
Provide a short and direct response. -12.12. What is the difference between the Mineral Rent(as % of GDP) of Coal in 2002 and the Mineral Rent(as % of GDP) of Oil in 2004?
Provide a succinct answer. -16.82. What is the difference between the Mineral Rent(as % of GDP) in Coal in 2002 and the Mineral Rent(as % of GDP) in Other Minerals in 2004?
Provide a short and direct response. -0.33. What is the difference between the Mineral Rent(as % of GDP) in Natural Gas in 2002 and the Mineral Rent(as % of GDP) in Oil in 2004?
Provide a short and direct response. -6.86. What is the difference between the Mineral Rent(as % of GDP) in Natural Gas in 2002 and the Mineral Rent(as % of GDP) in Other Minerals in 2004?
Offer a terse response. 9.62. What is the difference between the Mineral Rent(as % of GDP) in Oil in 2002 and the Mineral Rent(as % of GDP) in Other Minerals in 2004?
Ensure brevity in your answer.  13.75. What is the difference between the Mineral Rent(as % of GDP) of Coal in 2002 and the Mineral Rent(as % of GDP) of Natural Gas in 2005?
Make the answer very short. -15.64. What is the difference between the Mineral Rent(as % of GDP) of Coal in 2002 and the Mineral Rent(as % of GDP) of Oil in 2005?
Offer a terse response. -19.85. What is the difference between the Mineral Rent(as % of GDP) of Coal in 2002 and the Mineral Rent(as % of GDP) of Other Minerals in 2005?
Give a very brief answer. -0.65. What is the difference between the Mineral Rent(as % of GDP) in Natural Gas in 2002 and the Mineral Rent(as % of GDP) in Oil in 2005?
Ensure brevity in your answer.  -9.9. What is the difference between the Mineral Rent(as % of GDP) of Natural Gas in 2002 and the Mineral Rent(as % of GDP) of Other Minerals in 2005?
Keep it short and to the point. 9.31. What is the difference between the Mineral Rent(as % of GDP) of Oil in 2002 and the Mineral Rent(as % of GDP) of Other Minerals in 2005?
Offer a very short reply. 13.44. What is the difference between the Mineral Rent(as % of GDP) of Coal in 2003 and the Mineral Rent(as % of GDP) of Natural Gas in 2004?
Your response must be concise. -12.05. What is the difference between the Mineral Rent(as % of GDP) of Coal in 2003 and the Mineral Rent(as % of GDP) of Oil in 2004?
Offer a terse response. -16.75. What is the difference between the Mineral Rent(as % of GDP) in Coal in 2003 and the Mineral Rent(as % of GDP) in Other Minerals in 2004?
Provide a succinct answer. -0.26. What is the difference between the Mineral Rent(as % of GDP) in Natural Gas in 2003 and the Mineral Rent(as % of GDP) in Oil in 2004?
Your answer should be compact. -1.78. What is the difference between the Mineral Rent(as % of GDP) in Natural Gas in 2003 and the Mineral Rent(as % of GDP) in Other Minerals in 2004?
Give a very brief answer. 14.7. What is the difference between the Mineral Rent(as % of GDP) of Oil in 2003 and the Mineral Rent(as % of GDP) of Other Minerals in 2004?
Your response must be concise. 14.89. What is the difference between the Mineral Rent(as % of GDP) of Coal in 2003 and the Mineral Rent(as % of GDP) of Natural Gas in 2005?
Offer a terse response. -15.57. What is the difference between the Mineral Rent(as % of GDP) of Coal in 2003 and the Mineral Rent(as % of GDP) of Oil in 2005?
Offer a terse response. -19.78. What is the difference between the Mineral Rent(as % of GDP) in Coal in 2003 and the Mineral Rent(as % of GDP) in Other Minerals in 2005?
Your response must be concise. -0.58. What is the difference between the Mineral Rent(as % of GDP) of Natural Gas in 2003 and the Mineral Rent(as % of GDP) of Oil in 2005?
Ensure brevity in your answer.  -4.82. What is the difference between the Mineral Rent(as % of GDP) of Natural Gas in 2003 and the Mineral Rent(as % of GDP) of Other Minerals in 2005?
Offer a terse response. 14.39. What is the difference between the Mineral Rent(as % of GDP) of Oil in 2003 and the Mineral Rent(as % of GDP) of Other Minerals in 2005?
Your answer should be very brief. 14.57. What is the difference between the Mineral Rent(as % of GDP) in Coal in 2004 and the Mineral Rent(as % of GDP) in Natural Gas in 2005?
Provide a succinct answer. -14.82. What is the difference between the Mineral Rent(as % of GDP) in Coal in 2004 and the Mineral Rent(as % of GDP) in Oil in 2005?
Make the answer very short. -19.03. What is the difference between the Mineral Rent(as % of GDP) in Coal in 2004 and the Mineral Rent(as % of GDP) in Other Minerals in 2005?
Offer a terse response. 0.17. What is the difference between the Mineral Rent(as % of GDP) in Natural Gas in 2004 and the Mineral Rent(as % of GDP) in Oil in 2005?
Ensure brevity in your answer.  -7.73. What is the difference between the Mineral Rent(as % of GDP) of Natural Gas in 2004 and the Mineral Rent(as % of GDP) of Other Minerals in 2005?
Offer a terse response. 11.48. What is the difference between the Mineral Rent(as % of GDP) in Oil in 2004 and the Mineral Rent(as % of GDP) in Other Minerals in 2005?
Give a very brief answer. 16.17. What is the average Mineral Rent(as % of GDP) in Coal per year?
Keep it short and to the point. 0.48. What is the average Mineral Rent(as % of GDP) in Natural Gas per year?
Your answer should be compact. 12.9. What is the average Mineral Rent(as % of GDP) of Oil per year?
Provide a short and direct response. 14.26. What is the average Mineral Rent(as % of GDP) of Other Minerals per year?
Offer a terse response. 0.37. In the year 1997, what is the difference between the Mineral Rent(as % of GDP) in Coal and Mineral Rent(as % of GDP) in Natural Gas?
Provide a short and direct response. -7.1. In the year 1997, what is the difference between the Mineral Rent(as % of GDP) of Coal and Mineral Rent(as % of GDP) of Oil?
Ensure brevity in your answer.  -7.39. In the year 1997, what is the difference between the Mineral Rent(as % of GDP) of Coal and Mineral Rent(as % of GDP) of Other Minerals?
Your answer should be very brief. 0.16. In the year 1997, what is the difference between the Mineral Rent(as % of GDP) of Natural Gas and Mineral Rent(as % of GDP) of Oil?
Ensure brevity in your answer.  -0.29. In the year 1997, what is the difference between the Mineral Rent(as % of GDP) of Natural Gas and Mineral Rent(as % of GDP) of Other Minerals?
Make the answer very short. 7.27. In the year 1997, what is the difference between the Mineral Rent(as % of GDP) of Oil and Mineral Rent(as % of GDP) of Other Minerals?
Your answer should be very brief. 7.55. In the year 1998, what is the difference between the Mineral Rent(as % of GDP) of Coal and Mineral Rent(as % of GDP) of Natural Gas?
Keep it short and to the point. -8.08. In the year 1998, what is the difference between the Mineral Rent(as % of GDP) in Coal and Mineral Rent(as % of GDP) in Oil?
Your response must be concise. -5.75. In the year 1998, what is the difference between the Mineral Rent(as % of GDP) of Coal and Mineral Rent(as % of GDP) of Other Minerals?
Your answer should be very brief. 0.18. In the year 1998, what is the difference between the Mineral Rent(as % of GDP) in Natural Gas and Mineral Rent(as % of GDP) in Oil?
Ensure brevity in your answer.  2.33. In the year 1998, what is the difference between the Mineral Rent(as % of GDP) of Natural Gas and Mineral Rent(as % of GDP) of Other Minerals?
Your answer should be very brief. 8.26. In the year 1998, what is the difference between the Mineral Rent(as % of GDP) in Oil and Mineral Rent(as % of GDP) in Other Minerals?
Offer a very short reply. 5.93. In the year 1999, what is the difference between the Mineral Rent(as % of GDP) of Coal and Mineral Rent(as % of GDP) of Natural Gas?
Make the answer very short. -8.82. In the year 1999, what is the difference between the Mineral Rent(as % of GDP) in Coal and Mineral Rent(as % of GDP) in Oil?
Your answer should be compact. -12.53. In the year 1999, what is the difference between the Mineral Rent(as % of GDP) in Coal and Mineral Rent(as % of GDP) in Other Minerals?
Offer a terse response. 0.09. In the year 1999, what is the difference between the Mineral Rent(as % of GDP) in Natural Gas and Mineral Rent(as % of GDP) in Oil?
Offer a terse response. -3.71. In the year 1999, what is the difference between the Mineral Rent(as % of GDP) in Natural Gas and Mineral Rent(as % of GDP) in Other Minerals?
Ensure brevity in your answer.  8.91. In the year 1999, what is the difference between the Mineral Rent(as % of GDP) in Oil and Mineral Rent(as % of GDP) in Other Minerals?
Your answer should be compact. 12.62. In the year 2000, what is the difference between the Mineral Rent(as % of GDP) in Coal and Mineral Rent(as % of GDP) in Natural Gas?
Your answer should be compact. -20.56. In the year 2000, what is the difference between the Mineral Rent(as % of GDP) in Coal and Mineral Rent(as % of GDP) in Oil?
Provide a short and direct response. -19.81. In the year 2000, what is the difference between the Mineral Rent(as % of GDP) of Coal and Mineral Rent(as % of GDP) of Other Minerals?
Your answer should be compact. -0.22. In the year 2000, what is the difference between the Mineral Rent(as % of GDP) of Natural Gas and Mineral Rent(as % of GDP) of Oil?
Keep it short and to the point. 0.75. In the year 2000, what is the difference between the Mineral Rent(as % of GDP) in Natural Gas and Mineral Rent(as % of GDP) in Other Minerals?
Your response must be concise. 20.34. In the year 2000, what is the difference between the Mineral Rent(as % of GDP) in Oil and Mineral Rent(as % of GDP) in Other Minerals?
Keep it short and to the point. 19.59. In the year 2001, what is the difference between the Mineral Rent(as % of GDP) of Coal and Mineral Rent(as % of GDP) of Natural Gas?
Ensure brevity in your answer.  -15.78. In the year 2001, what is the difference between the Mineral Rent(as % of GDP) in Coal and Mineral Rent(as % of GDP) in Oil?
Ensure brevity in your answer.  -13.86. In the year 2001, what is the difference between the Mineral Rent(as % of GDP) of Coal and Mineral Rent(as % of GDP) of Other Minerals?
Keep it short and to the point. 0.59. In the year 2001, what is the difference between the Mineral Rent(as % of GDP) of Natural Gas and Mineral Rent(as % of GDP) of Oil?
Ensure brevity in your answer.  1.92. In the year 2001, what is the difference between the Mineral Rent(as % of GDP) of Natural Gas and Mineral Rent(as % of GDP) of Other Minerals?
Offer a terse response. 16.37. In the year 2001, what is the difference between the Mineral Rent(as % of GDP) in Oil and Mineral Rent(as % of GDP) in Other Minerals?
Make the answer very short. 14.45. In the year 2002, what is the difference between the Mineral Rent(as % of GDP) in Coal and Mineral Rent(as % of GDP) in Natural Gas?
Ensure brevity in your answer.  -9.95. In the year 2002, what is the difference between the Mineral Rent(as % of GDP) of Coal and Mineral Rent(as % of GDP) of Oil?
Keep it short and to the point. -14.08. In the year 2002, what is the difference between the Mineral Rent(as % of GDP) in Coal and Mineral Rent(as % of GDP) in Other Minerals?
Your answer should be very brief. 0.04. In the year 2002, what is the difference between the Mineral Rent(as % of GDP) of Natural Gas and Mineral Rent(as % of GDP) of Oil?
Provide a succinct answer. -4.13. In the year 2002, what is the difference between the Mineral Rent(as % of GDP) in Natural Gas and Mineral Rent(as % of GDP) in Other Minerals?
Your answer should be very brief. 10. In the year 2002, what is the difference between the Mineral Rent(as % of GDP) of Oil and Mineral Rent(as % of GDP) of Other Minerals?
Provide a succinct answer. 14.13. In the year 2003, what is the difference between the Mineral Rent(as % of GDP) of Coal and Mineral Rent(as % of GDP) of Natural Gas?
Offer a very short reply. -14.97. In the year 2003, what is the difference between the Mineral Rent(as % of GDP) in Coal and Mineral Rent(as % of GDP) in Oil?
Make the answer very short. -15.15. In the year 2003, what is the difference between the Mineral Rent(as % of GDP) in Coal and Mineral Rent(as % of GDP) in Other Minerals?
Your response must be concise. -0.1. In the year 2003, what is the difference between the Mineral Rent(as % of GDP) in Natural Gas and Mineral Rent(as % of GDP) in Oil?
Your response must be concise. -0.18. In the year 2003, what is the difference between the Mineral Rent(as % of GDP) in Natural Gas and Mineral Rent(as % of GDP) in Other Minerals?
Your answer should be very brief. 14.87. In the year 2003, what is the difference between the Mineral Rent(as % of GDP) of Oil and Mineral Rent(as % of GDP) of Other Minerals?
Make the answer very short. 15.05. In the year 2004, what is the difference between the Mineral Rent(as % of GDP) of Coal and Mineral Rent(as % of GDP) of Natural Gas?
Provide a short and direct response. -11.3. In the year 2004, what is the difference between the Mineral Rent(as % of GDP) in Coal and Mineral Rent(as % of GDP) in Oil?
Your answer should be very brief. -15.99. In the year 2004, what is the difference between the Mineral Rent(as % of GDP) of Coal and Mineral Rent(as % of GDP) of Other Minerals?
Give a very brief answer. 0.49. In the year 2004, what is the difference between the Mineral Rent(as % of GDP) of Natural Gas and Mineral Rent(as % of GDP) of Oil?
Make the answer very short. -4.69. In the year 2004, what is the difference between the Mineral Rent(as % of GDP) of Natural Gas and Mineral Rent(as % of GDP) of Other Minerals?
Make the answer very short. 11.79. In the year 2004, what is the difference between the Mineral Rent(as % of GDP) in Oil and Mineral Rent(as % of GDP) in Other Minerals?
Give a very brief answer. 16.48. In the year 2005, what is the difference between the Mineral Rent(as % of GDP) of Coal and Mineral Rent(as % of GDP) of Natural Gas?
Make the answer very short. -15.26. In the year 2005, what is the difference between the Mineral Rent(as % of GDP) of Coal and Mineral Rent(as % of GDP) of Oil?
Provide a succinct answer. -19.47. In the year 2005, what is the difference between the Mineral Rent(as % of GDP) in Coal and Mineral Rent(as % of GDP) in Other Minerals?
Make the answer very short. -0.26. In the year 2005, what is the difference between the Mineral Rent(as % of GDP) of Natural Gas and Mineral Rent(as % of GDP) of Oil?
Provide a succinct answer. -4.21. In the year 2005, what is the difference between the Mineral Rent(as % of GDP) of Natural Gas and Mineral Rent(as % of GDP) of Other Minerals?
Your response must be concise. 14.99. In the year 2005, what is the difference between the Mineral Rent(as % of GDP) in Oil and Mineral Rent(as % of GDP) in Other Minerals?
Your answer should be compact. 19.21. What is the ratio of the Mineral Rent(as % of GDP) in Coal in 1997 to that in 1998?
Provide a short and direct response. 1.35. What is the ratio of the Mineral Rent(as % of GDP) of Natural Gas in 1997 to that in 1998?
Your answer should be compact. 0.89. What is the ratio of the Mineral Rent(as % of GDP) of Oil in 1997 to that in 1998?
Keep it short and to the point. 1.29. What is the ratio of the Mineral Rent(as % of GDP) in Other Minerals in 1997 to that in 1998?
Provide a succinct answer. 2.3. What is the ratio of the Mineral Rent(as % of GDP) in Coal in 1997 to that in 1999?
Keep it short and to the point. 1.82. What is the ratio of the Mineral Rent(as % of GDP) in Natural Gas in 1997 to that in 1999?
Keep it short and to the point. 0.83. What is the ratio of the Mineral Rent(as % of GDP) in Oil in 1997 to that in 1999?
Make the answer very short. 0.61. What is the ratio of the Mineral Rent(as % of GDP) of Other Minerals in 1997 to that in 1999?
Keep it short and to the point. 1.79. What is the ratio of the Mineral Rent(as % of GDP) in Coal in 1997 to that in 2000?
Provide a succinct answer. 1.37. What is the ratio of the Mineral Rent(as % of GDP) of Natural Gas in 1997 to that in 2000?
Offer a very short reply. 0.36. What is the ratio of the Mineral Rent(as % of GDP) in Oil in 1997 to that in 2000?
Make the answer very short. 0.39. What is the ratio of the Mineral Rent(as % of GDP) in Other Minerals in 1997 to that in 2000?
Provide a succinct answer. 0.41. What is the ratio of the Mineral Rent(as % of GDP) in Coal in 1997 to that in 2001?
Give a very brief answer. 0.5. What is the ratio of the Mineral Rent(as % of GDP) in Natural Gas in 1997 to that in 2001?
Your answer should be compact. 0.45. What is the ratio of the Mineral Rent(as % of GDP) in Oil in 1997 to that in 2001?
Keep it short and to the point. 0.53. What is the ratio of the Mineral Rent(as % of GDP) of Other Minerals in 1997 to that in 2001?
Offer a very short reply. 1.54. What is the ratio of the Mineral Rent(as % of GDP) in Coal in 1997 to that in 2002?
Keep it short and to the point. 1.18. What is the ratio of the Mineral Rent(as % of GDP) of Natural Gas in 1997 to that in 2002?
Your answer should be very brief. 0.73. What is the ratio of the Mineral Rent(as % of GDP) in Oil in 1997 to that in 2002?
Give a very brief answer. 0.54. What is the ratio of the Mineral Rent(as % of GDP) of Other Minerals in 1997 to that in 2002?
Your answer should be compact. 0.74. What is the ratio of the Mineral Rent(as % of GDP) of Coal in 1997 to that in 2003?
Ensure brevity in your answer.  0.96. What is the ratio of the Mineral Rent(as % of GDP) in Natural Gas in 1997 to that in 2003?
Ensure brevity in your answer.  0.49. What is the ratio of the Mineral Rent(as % of GDP) in Oil in 1997 to that in 2003?
Make the answer very short. 0.5. What is the ratio of the Mineral Rent(as % of GDP) in Other Minerals in 1997 to that in 2003?
Your answer should be very brief. 0.41. What is the ratio of the Mineral Rent(as % of GDP) of Coal in 1997 to that in 2004?
Ensure brevity in your answer.  0.32. What is the ratio of the Mineral Rent(as % of GDP) of Natural Gas in 1997 to that in 2004?
Give a very brief answer. 0.6. What is the ratio of the Mineral Rent(as % of GDP) in Oil in 1997 to that in 2004?
Provide a short and direct response. 0.45. What is the ratio of the Mineral Rent(as % of GDP) of Other Minerals in 1997 to that in 2004?
Your answer should be very brief. 0.31. What is the ratio of the Mineral Rent(as % of GDP) in Coal in 1997 to that in 2005?
Offer a terse response. 0.52. What is the ratio of the Mineral Rent(as % of GDP) in Natural Gas in 1997 to that in 2005?
Provide a short and direct response. 0.47. What is the ratio of the Mineral Rent(as % of GDP) in Oil in 1997 to that in 2005?
Offer a very short reply. 0.38. What is the ratio of the Mineral Rent(as % of GDP) of Other Minerals in 1997 to that in 2005?
Ensure brevity in your answer.  0.21. What is the ratio of the Mineral Rent(as % of GDP) in Coal in 1998 to that in 1999?
Provide a succinct answer. 1.34. What is the ratio of the Mineral Rent(as % of GDP) in Natural Gas in 1998 to that in 1999?
Offer a very short reply. 0.93. What is the ratio of the Mineral Rent(as % of GDP) of Oil in 1998 to that in 1999?
Your response must be concise. 0.47. What is the ratio of the Mineral Rent(as % of GDP) in Other Minerals in 1998 to that in 1999?
Ensure brevity in your answer.  0.78. What is the ratio of the Mineral Rent(as % of GDP) of Coal in 1998 to that in 2000?
Your answer should be very brief. 1.01. What is the ratio of the Mineral Rent(as % of GDP) in Natural Gas in 1998 to that in 2000?
Offer a terse response. 0.4. What is the ratio of the Mineral Rent(as % of GDP) in Oil in 1998 to that in 2000?
Your answer should be very brief. 0.3. What is the ratio of the Mineral Rent(as % of GDP) in Other Minerals in 1998 to that in 2000?
Keep it short and to the point. 0.18. What is the ratio of the Mineral Rent(as % of GDP) in Coal in 1998 to that in 2001?
Your response must be concise. 0.37. What is the ratio of the Mineral Rent(as % of GDP) of Natural Gas in 1998 to that in 2001?
Keep it short and to the point. 0.51. What is the ratio of the Mineral Rent(as % of GDP) in Oil in 1998 to that in 2001?
Make the answer very short. 0.41. What is the ratio of the Mineral Rent(as % of GDP) of Other Minerals in 1998 to that in 2001?
Provide a succinct answer. 0.67. What is the ratio of the Mineral Rent(as % of GDP) in Coal in 1998 to that in 2002?
Offer a terse response. 0.87. What is the ratio of the Mineral Rent(as % of GDP) of Natural Gas in 1998 to that in 2002?
Ensure brevity in your answer.  0.81. What is the ratio of the Mineral Rent(as % of GDP) in Oil in 1998 to that in 2002?
Your answer should be compact. 0.42. What is the ratio of the Mineral Rent(as % of GDP) in Other Minerals in 1998 to that in 2002?
Give a very brief answer. 0.32. What is the ratio of the Mineral Rent(as % of GDP) in Coal in 1998 to that in 2003?
Your answer should be very brief. 0.71. What is the ratio of the Mineral Rent(as % of GDP) of Natural Gas in 1998 to that in 2003?
Make the answer very short. 0.54. What is the ratio of the Mineral Rent(as % of GDP) of Oil in 1998 to that in 2003?
Your answer should be very brief. 0.39. What is the ratio of the Mineral Rent(as % of GDP) of Other Minerals in 1998 to that in 2003?
Ensure brevity in your answer.  0.18. What is the ratio of the Mineral Rent(as % of GDP) in Coal in 1998 to that in 2004?
Your response must be concise. 0.24. What is the ratio of the Mineral Rent(as % of GDP) of Natural Gas in 1998 to that in 2004?
Your response must be concise. 0.67. What is the ratio of the Mineral Rent(as % of GDP) in Oil in 1998 to that in 2004?
Provide a short and direct response. 0.35. What is the ratio of the Mineral Rent(as % of GDP) of Other Minerals in 1998 to that in 2004?
Keep it short and to the point. 0.13. What is the ratio of the Mineral Rent(as % of GDP) in Coal in 1998 to that in 2005?
Offer a terse response. 0.39. What is the ratio of the Mineral Rent(as % of GDP) in Natural Gas in 1998 to that in 2005?
Ensure brevity in your answer.  0.52. What is the ratio of the Mineral Rent(as % of GDP) in Oil in 1998 to that in 2005?
Your answer should be very brief. 0.3. What is the ratio of the Mineral Rent(as % of GDP) in Other Minerals in 1998 to that in 2005?
Give a very brief answer. 0.09. What is the ratio of the Mineral Rent(as % of GDP) in Coal in 1999 to that in 2000?
Provide a succinct answer. 0.75. What is the ratio of the Mineral Rent(as % of GDP) of Natural Gas in 1999 to that in 2000?
Your answer should be very brief. 0.43. What is the ratio of the Mineral Rent(as % of GDP) in Oil in 1999 to that in 2000?
Your answer should be very brief. 0.63. What is the ratio of the Mineral Rent(as % of GDP) in Other Minerals in 1999 to that in 2000?
Provide a short and direct response. 0.23. What is the ratio of the Mineral Rent(as % of GDP) in Coal in 1999 to that in 2001?
Offer a terse response. 0.28. What is the ratio of the Mineral Rent(as % of GDP) of Natural Gas in 1999 to that in 2001?
Your response must be concise. 0.55. What is the ratio of the Mineral Rent(as % of GDP) in Oil in 1999 to that in 2001?
Offer a very short reply. 0.87. What is the ratio of the Mineral Rent(as % of GDP) of Other Minerals in 1999 to that in 2001?
Give a very brief answer. 0.86. What is the ratio of the Mineral Rent(as % of GDP) in Coal in 1999 to that in 2002?
Keep it short and to the point. 0.65. What is the ratio of the Mineral Rent(as % of GDP) in Natural Gas in 1999 to that in 2002?
Offer a very short reply. 0.88. What is the ratio of the Mineral Rent(as % of GDP) of Oil in 1999 to that in 2002?
Your response must be concise. 0.88. What is the ratio of the Mineral Rent(as % of GDP) of Other Minerals in 1999 to that in 2002?
Your answer should be compact. 0.42. What is the ratio of the Mineral Rent(as % of GDP) of Coal in 1999 to that in 2003?
Your answer should be compact. 0.53. What is the ratio of the Mineral Rent(as % of GDP) of Natural Gas in 1999 to that in 2003?
Give a very brief answer. 0.59. What is the ratio of the Mineral Rent(as % of GDP) in Oil in 1999 to that in 2003?
Keep it short and to the point. 0.82. What is the ratio of the Mineral Rent(as % of GDP) in Other Minerals in 1999 to that in 2003?
Your answer should be compact. 0.23. What is the ratio of the Mineral Rent(as % of GDP) in Coal in 1999 to that in 2004?
Give a very brief answer. 0.18. What is the ratio of the Mineral Rent(as % of GDP) of Natural Gas in 1999 to that in 2004?
Offer a very short reply. 0.73. What is the ratio of the Mineral Rent(as % of GDP) of Oil in 1999 to that in 2004?
Keep it short and to the point. 0.74. What is the ratio of the Mineral Rent(as % of GDP) in Other Minerals in 1999 to that in 2004?
Make the answer very short. 0.17. What is the ratio of the Mineral Rent(as % of GDP) of Coal in 1999 to that in 2005?
Give a very brief answer. 0.29. What is the ratio of the Mineral Rent(as % of GDP) in Natural Gas in 1999 to that in 2005?
Provide a succinct answer. 0.57. What is the ratio of the Mineral Rent(as % of GDP) of Oil in 1999 to that in 2005?
Offer a very short reply. 0.63. What is the ratio of the Mineral Rent(as % of GDP) of Other Minerals in 1999 to that in 2005?
Offer a very short reply. 0.11. What is the ratio of the Mineral Rent(as % of GDP) in Coal in 2000 to that in 2001?
Make the answer very short. 0.36. What is the ratio of the Mineral Rent(as % of GDP) in Natural Gas in 2000 to that in 2001?
Provide a short and direct response. 1.26. What is the ratio of the Mineral Rent(as % of GDP) in Oil in 2000 to that in 2001?
Ensure brevity in your answer.  1.38. What is the ratio of the Mineral Rent(as % of GDP) in Other Minerals in 2000 to that in 2001?
Offer a terse response. 3.79. What is the ratio of the Mineral Rent(as % of GDP) of Coal in 2000 to that in 2002?
Your answer should be compact. 0.86. What is the ratio of the Mineral Rent(as % of GDP) of Natural Gas in 2000 to that in 2002?
Provide a short and direct response. 2.03. What is the ratio of the Mineral Rent(as % of GDP) of Oil in 2000 to that in 2002?
Your answer should be very brief. 1.39. What is the ratio of the Mineral Rent(as % of GDP) in Other Minerals in 2000 to that in 2002?
Your answer should be very brief. 1.83. What is the ratio of the Mineral Rent(as % of GDP) in Coal in 2000 to that in 2003?
Give a very brief answer. 0.7. What is the ratio of the Mineral Rent(as % of GDP) in Natural Gas in 2000 to that in 2003?
Your answer should be very brief. 1.36. What is the ratio of the Mineral Rent(as % of GDP) of Oil in 2000 to that in 2003?
Provide a short and direct response. 1.29. What is the ratio of the Mineral Rent(as % of GDP) of Other Minerals in 2000 to that in 2003?
Offer a terse response. 1.01. What is the ratio of the Mineral Rent(as % of GDP) in Coal in 2000 to that in 2004?
Your answer should be very brief. 0.23. What is the ratio of the Mineral Rent(as % of GDP) of Natural Gas in 2000 to that in 2004?
Provide a short and direct response. 1.68. What is the ratio of the Mineral Rent(as % of GDP) of Oil in 2000 to that in 2004?
Your response must be concise. 1.17. What is the ratio of the Mineral Rent(as % of GDP) of Other Minerals in 2000 to that in 2004?
Your answer should be compact. 0.75. What is the ratio of the Mineral Rent(as % of GDP) in Coal in 2000 to that in 2005?
Provide a short and direct response. 0.38. What is the ratio of the Mineral Rent(as % of GDP) in Natural Gas in 2000 to that in 2005?
Give a very brief answer. 1.31. What is the ratio of the Mineral Rent(as % of GDP) of Oil in 2000 to that in 2005?
Make the answer very short. 1. What is the ratio of the Mineral Rent(as % of GDP) of Other Minerals in 2000 to that in 2005?
Your response must be concise. 0.5. What is the ratio of the Mineral Rent(as % of GDP) in Coal in 2001 to that in 2002?
Provide a short and direct response. 2.35. What is the ratio of the Mineral Rent(as % of GDP) in Natural Gas in 2001 to that in 2002?
Offer a terse response. 1.61. What is the ratio of the Mineral Rent(as % of GDP) of Oil in 2001 to that in 2002?
Offer a terse response. 1.01. What is the ratio of the Mineral Rent(as % of GDP) in Other Minerals in 2001 to that in 2002?
Offer a terse response. 0.48. What is the ratio of the Mineral Rent(as % of GDP) in Coal in 2001 to that in 2003?
Offer a terse response. 1.91. What is the ratio of the Mineral Rent(as % of GDP) of Natural Gas in 2001 to that in 2003?
Ensure brevity in your answer.  1.08. What is the ratio of the Mineral Rent(as % of GDP) of Oil in 2001 to that in 2003?
Ensure brevity in your answer.  0.94. What is the ratio of the Mineral Rent(as % of GDP) in Other Minerals in 2001 to that in 2003?
Provide a succinct answer. 0.27. What is the ratio of the Mineral Rent(as % of GDP) in Coal in 2001 to that in 2004?
Provide a succinct answer. 0.64. What is the ratio of the Mineral Rent(as % of GDP) of Natural Gas in 2001 to that in 2004?
Offer a very short reply. 1.33. What is the ratio of the Mineral Rent(as % of GDP) of Oil in 2001 to that in 2004?
Offer a very short reply. 0.85. What is the ratio of the Mineral Rent(as % of GDP) of Other Minerals in 2001 to that in 2004?
Provide a short and direct response. 0.2. What is the ratio of the Mineral Rent(as % of GDP) in Coal in 2001 to that in 2005?
Offer a terse response. 1.04. What is the ratio of the Mineral Rent(as % of GDP) in Natural Gas in 2001 to that in 2005?
Ensure brevity in your answer.  1.03. What is the ratio of the Mineral Rent(as % of GDP) in Oil in 2001 to that in 2005?
Provide a succinct answer. 0.72. What is the ratio of the Mineral Rent(as % of GDP) of Other Minerals in 2001 to that in 2005?
Provide a succinct answer. 0.13. What is the ratio of the Mineral Rent(as % of GDP) of Coal in 2002 to that in 2003?
Give a very brief answer. 0.81. What is the ratio of the Mineral Rent(as % of GDP) of Natural Gas in 2002 to that in 2003?
Give a very brief answer. 0.67. What is the ratio of the Mineral Rent(as % of GDP) in Oil in 2002 to that in 2003?
Ensure brevity in your answer.  0.93. What is the ratio of the Mineral Rent(as % of GDP) of Other Minerals in 2002 to that in 2003?
Your answer should be compact. 0.55. What is the ratio of the Mineral Rent(as % of GDP) of Coal in 2002 to that in 2004?
Keep it short and to the point. 0.27. What is the ratio of the Mineral Rent(as % of GDP) in Natural Gas in 2002 to that in 2004?
Your answer should be very brief. 0.83. What is the ratio of the Mineral Rent(as % of GDP) of Oil in 2002 to that in 2004?
Provide a short and direct response. 0.84. What is the ratio of the Mineral Rent(as % of GDP) in Other Minerals in 2002 to that in 2004?
Provide a succinct answer. 0.41. What is the ratio of the Mineral Rent(as % of GDP) in Coal in 2002 to that in 2005?
Make the answer very short. 0.44. What is the ratio of the Mineral Rent(as % of GDP) in Natural Gas in 2002 to that in 2005?
Keep it short and to the point. 0.64. What is the ratio of the Mineral Rent(as % of GDP) in Oil in 2002 to that in 2005?
Ensure brevity in your answer.  0.71. What is the ratio of the Mineral Rent(as % of GDP) in Other Minerals in 2002 to that in 2005?
Give a very brief answer. 0.28. What is the ratio of the Mineral Rent(as % of GDP) in Natural Gas in 2003 to that in 2004?
Provide a short and direct response. 1.23. What is the ratio of the Mineral Rent(as % of GDP) in Oil in 2003 to that in 2004?
Your response must be concise. 0.91. What is the ratio of the Mineral Rent(as % of GDP) in Other Minerals in 2003 to that in 2004?
Your answer should be very brief. 0.74. What is the ratio of the Mineral Rent(as % of GDP) of Coal in 2003 to that in 2005?
Your response must be concise. 0.54. What is the ratio of the Mineral Rent(as % of GDP) in Natural Gas in 2003 to that in 2005?
Your answer should be very brief. 0.96. What is the ratio of the Mineral Rent(as % of GDP) of Oil in 2003 to that in 2005?
Make the answer very short. 0.77. What is the ratio of the Mineral Rent(as % of GDP) of Other Minerals in 2003 to that in 2005?
Make the answer very short. 0.5. What is the ratio of the Mineral Rent(as % of GDP) of Coal in 2004 to that in 2005?
Offer a terse response. 1.63. What is the ratio of the Mineral Rent(as % of GDP) of Natural Gas in 2004 to that in 2005?
Give a very brief answer. 0.78. What is the ratio of the Mineral Rent(as % of GDP) of Oil in 2004 to that in 2005?
Make the answer very short. 0.85. What is the ratio of the Mineral Rent(as % of GDP) in Other Minerals in 2004 to that in 2005?
Ensure brevity in your answer.  0.67. What is the difference between the highest and the second highest Mineral Rent(as % of GDP) of Coal?
Give a very brief answer. 0.41. What is the difference between the highest and the second highest Mineral Rent(as % of GDP) in Natural Gas?
Your answer should be compact. 4.33. What is the difference between the highest and the second highest Mineral Rent(as % of GDP) in Oil?
Your answer should be very brief. 0.09. What is the difference between the highest and the second highest Mineral Rent(as % of GDP) of Other Minerals?
Provide a succinct answer. 0.31. What is the difference between the highest and the lowest Mineral Rent(as % of GDP) of Coal?
Your answer should be compact. 0.93. What is the difference between the highest and the lowest Mineral Rent(as % of GDP) in Natural Gas?
Your answer should be very brief. 13.36. What is the difference between the highest and the lowest Mineral Rent(as % of GDP) in Oil?
Make the answer very short. 14.14. What is the difference between the highest and the lowest Mineral Rent(as % of GDP) of Other Minerals?
Provide a succinct answer. 0.87. 